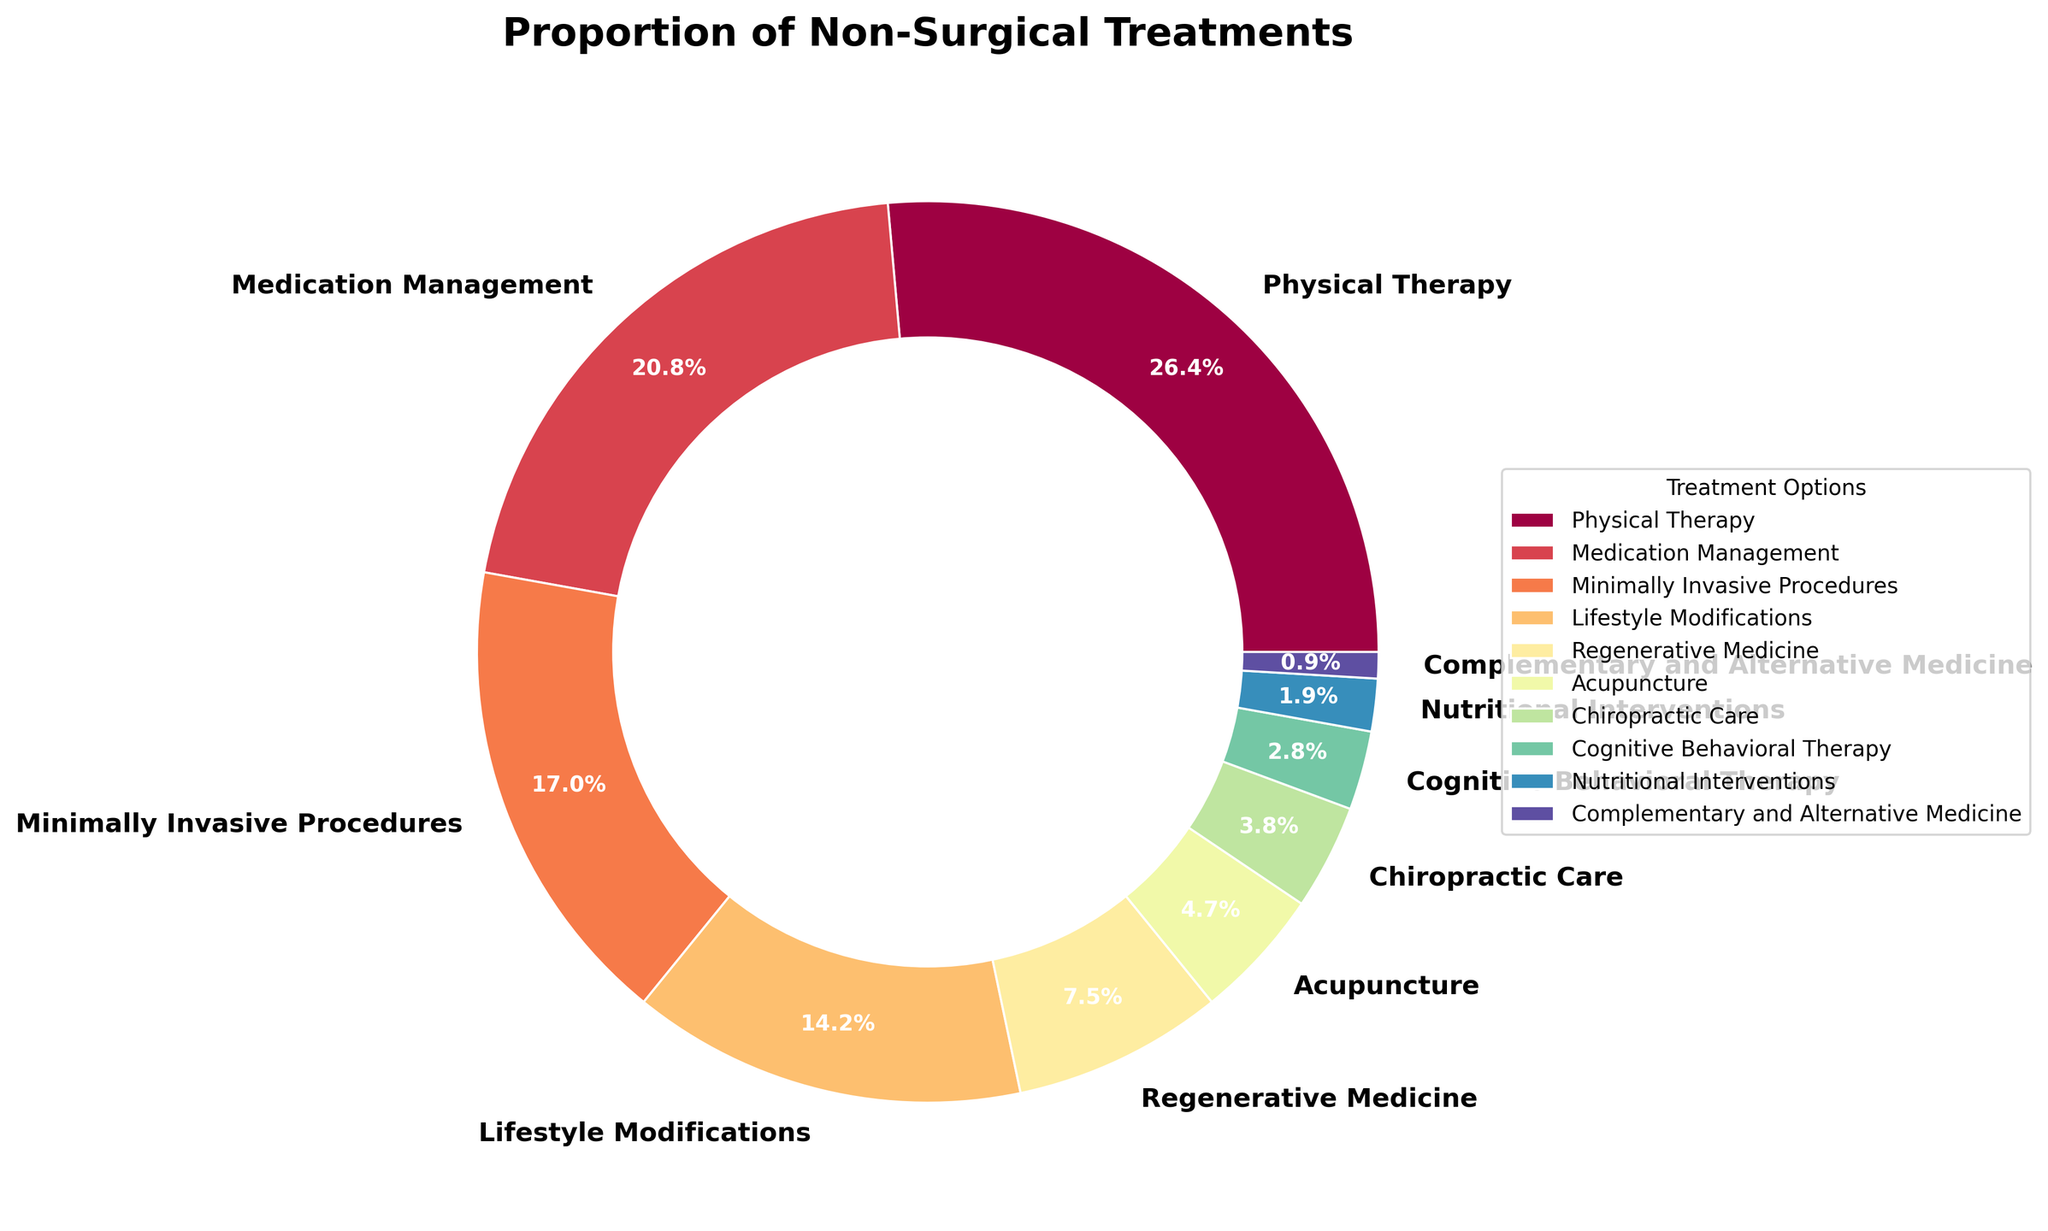What's the most common non-surgical treatment option? By looking at the pie chart, the slice with the largest percentage represents the most common treatment option, which is 'Physical Therapy' with 28%.
Answer: Physical Therapy Which treatment option is the least common? The smallest slice on the pie chart represents the least common treatment option, which is 'Complementary and Alternative Medicine' with 1%.
Answer: Complementary and Alternative Medicine What is the combined percentage of patients opting for Lifestyle Modifications and Medication Management? According to the pie chart, Lifestyle Modifications is 15% and Medication Management is 22%. Adding these together gives 15% + 22% = 37%.
Answer: 37% How many treatment options make up exactly half of the total percentage? By adding the percentages in descending order: 28% (Physical Therapy) + 22% (Medication Management) = 50%. Thus, two treatment options make up exactly half of the total.
Answer: 2 Is the percentage of patients opting for Cognitive Behavioral Therapy greater than that opting for Chiropractic Care? The pie chart shows Cognitive Behavioral Therapy at 3% and Chiropractic Care at 4%. 3% is less than 4%.
Answer: No What is the difference in percentage between the highest and lowest treatment options? The highest percentage is 'Physical Therapy' with 28%, and the lowest is 'Complementary and Alternative Medicine' with 1%. The difference is 28% - 1% = 27%.
Answer: 27% Which treatment option has a percentage closer to the average percentage of all options shown? First, calculate the average percentage: (28% + 22% + 18% + 15% + 8% + 5% + 4% + 3% + 2% + 1%) / 10 = 106%/10 = 10.6%. The treatment option closest to this value is 'Regenerative Medicine' at 8%.
Answer: Regenerative Medicine Between Regenerative Medicine and Acupuncture, which is more popular, and by how much? The pie chart shows Regenerative Medicine at 8% and Acupuncture at 5%. The difference in popularity is 8% - 5% = 3%.
Answer: Regenerative Medicine by 3% If you combine all the options below 10%, what percentage do they represent in total? Adding up the percentages of Regenerative Medicine (8%), Acupuncture (5%), Chiropractic Care (4%), Cognitive Behavioral Therapy (3%), Nutritional Interventions (2%), and Complementary and Alternative Medicine (1%), you get 8% + 5% + 4% + 3% + 2% + 1% = 23%.
Answer: 23% Among Physical Therapy, Medication Management, and Minimally Invasive Procedures, which is the least popular? Looking at the pie chart, the percentages are as follows: Physical Therapy (28%), Medication Management (22%), and Minimally Invasive Procedures (18%). The least popular among these is Minimally Invasive Procedures.
Answer: Minimally Invasive Procedures 